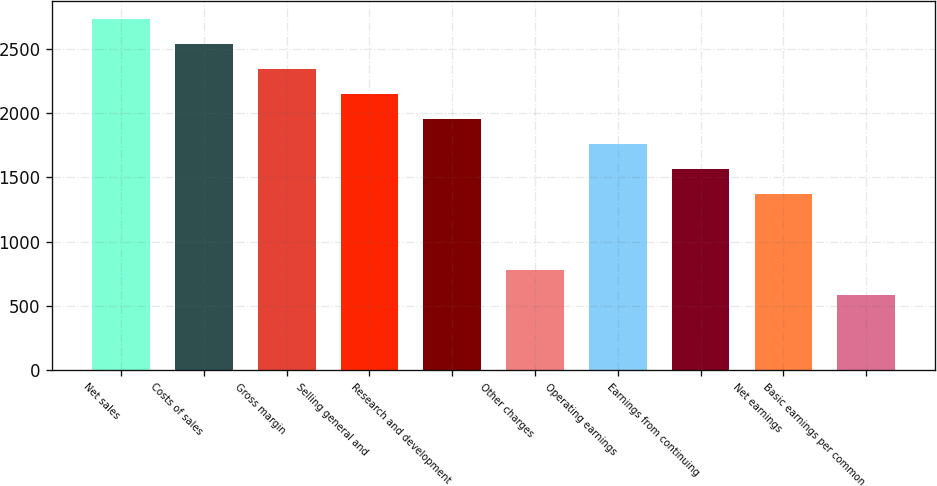Convert chart to OTSL. <chart><loc_0><loc_0><loc_500><loc_500><bar_chart><fcel>Net sales<fcel>Costs of sales<fcel>Gross margin<fcel>Selling general and<fcel>Research and development<fcel>Other charges<fcel>Operating earnings<fcel>Earnings from continuing<fcel>Net earnings<fcel>Basic earnings per common<nl><fcel>2738.34<fcel>2542.76<fcel>2347.18<fcel>2151.6<fcel>1956.02<fcel>782.54<fcel>1760.44<fcel>1564.86<fcel>1369.28<fcel>586.96<nl></chart> 